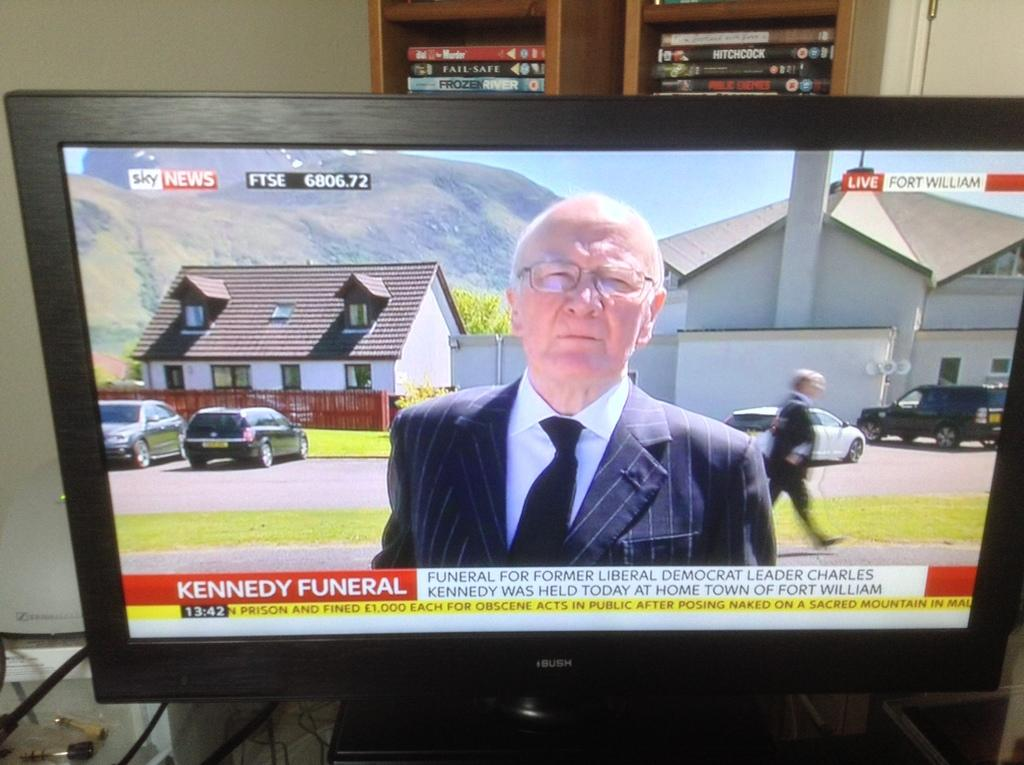<image>
Share a concise interpretation of the image provided. A television shows the Kennedy Funeral on a news program. 